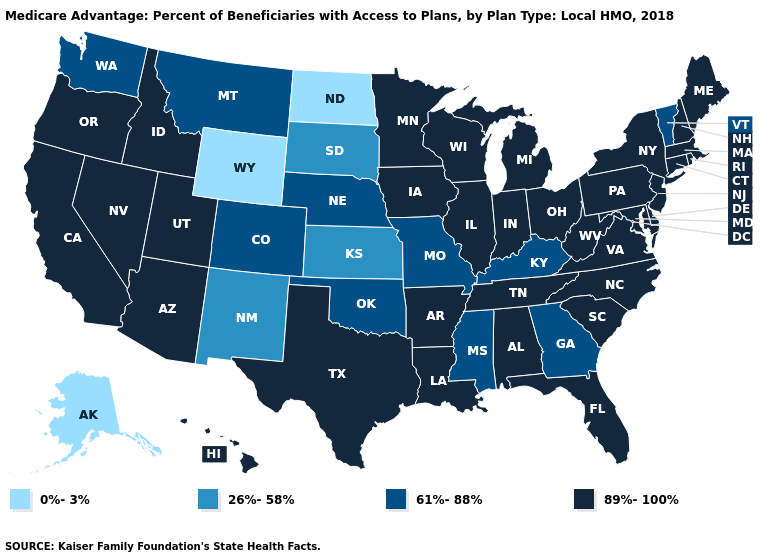Which states have the highest value in the USA?
Give a very brief answer. California, Connecticut, Delaware, Florida, Hawaii, Iowa, Idaho, Illinois, Indiana, Louisiana, Massachusetts, Maryland, Maine, Michigan, Minnesota, North Carolina, New Hampshire, New Jersey, Nevada, New York, Ohio, Oregon, Pennsylvania, Rhode Island, South Carolina, Tennessee, Texas, Utah, Virginia, Wisconsin, West Virginia, Alabama, Arkansas, Arizona. What is the value of Virginia?
Short answer required. 89%-100%. Does New York have a lower value than Alaska?
Concise answer only. No. What is the value of Colorado?
Write a very short answer. 61%-88%. Name the states that have a value in the range 89%-100%?
Write a very short answer. California, Connecticut, Delaware, Florida, Hawaii, Iowa, Idaho, Illinois, Indiana, Louisiana, Massachusetts, Maryland, Maine, Michigan, Minnesota, North Carolina, New Hampshire, New Jersey, Nevada, New York, Ohio, Oregon, Pennsylvania, Rhode Island, South Carolina, Tennessee, Texas, Utah, Virginia, Wisconsin, West Virginia, Alabama, Arkansas, Arizona. What is the value of Massachusetts?
Keep it brief. 89%-100%. What is the value of Alabama?
Concise answer only. 89%-100%. What is the value of Kansas?
Answer briefly. 26%-58%. What is the highest value in the USA?
Give a very brief answer. 89%-100%. Name the states that have a value in the range 0%-3%?
Write a very short answer. North Dakota, Alaska, Wyoming. Name the states that have a value in the range 89%-100%?
Answer briefly. California, Connecticut, Delaware, Florida, Hawaii, Iowa, Idaho, Illinois, Indiana, Louisiana, Massachusetts, Maryland, Maine, Michigan, Minnesota, North Carolina, New Hampshire, New Jersey, Nevada, New York, Ohio, Oregon, Pennsylvania, Rhode Island, South Carolina, Tennessee, Texas, Utah, Virginia, Wisconsin, West Virginia, Alabama, Arkansas, Arizona. What is the value of Oklahoma?
Write a very short answer. 61%-88%. What is the value of Connecticut?
Give a very brief answer. 89%-100%. Which states have the lowest value in the South?
Concise answer only. Georgia, Kentucky, Mississippi, Oklahoma. What is the value of Mississippi?
Give a very brief answer. 61%-88%. 